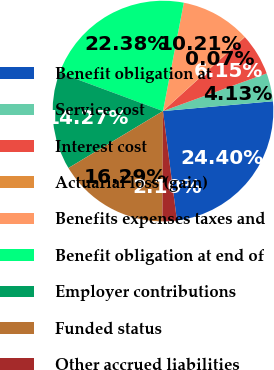<chart> <loc_0><loc_0><loc_500><loc_500><pie_chart><fcel>Benefit obligation at<fcel>Service cost<fcel>Interest cost<fcel>Actuarial loss (gain)<fcel>Benefits expenses taxes and<fcel>Benefit obligation at end of<fcel>Employer contributions<fcel>Funded status<fcel>Other accrued liabilities<nl><fcel>24.4%<fcel>4.13%<fcel>6.15%<fcel>0.07%<fcel>10.21%<fcel>22.38%<fcel>14.27%<fcel>16.29%<fcel>2.1%<nl></chart> 